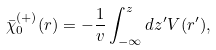<formula> <loc_0><loc_0><loc_500><loc_500>\bar { \chi } ^ { ( + ) } _ { 0 } ( { r } ) = - \frac { 1 } { v } \int _ { - \infty } ^ { z } d z ^ { \prime } V ( r ^ { \prime } ) ,</formula> 